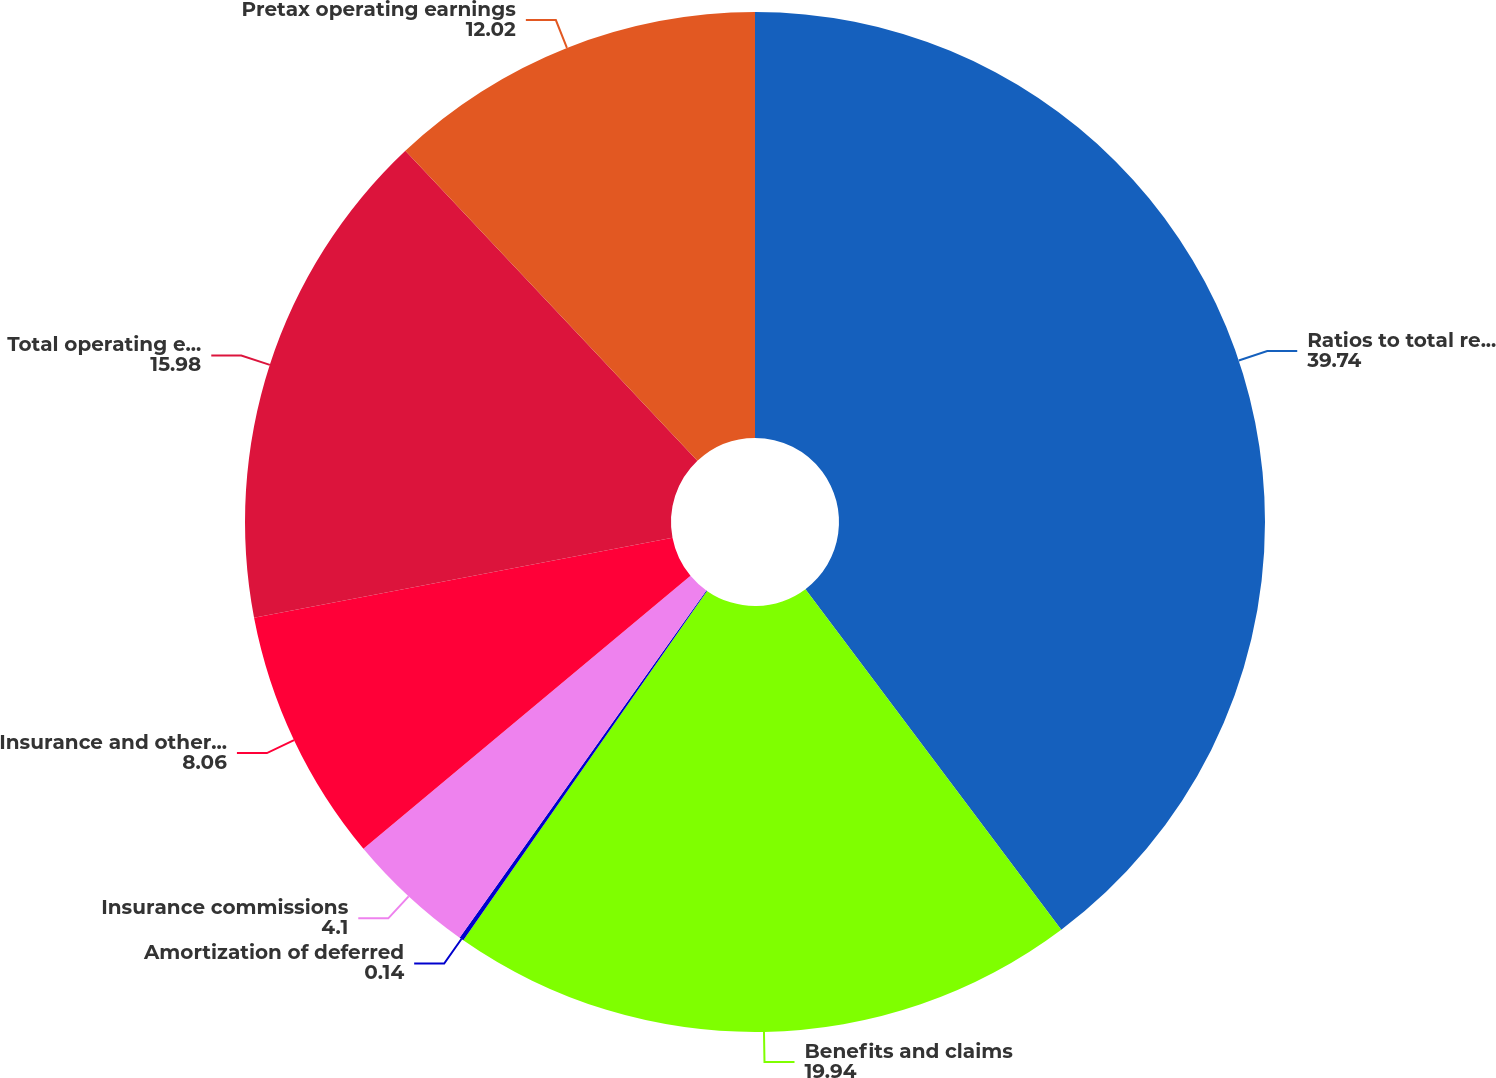Convert chart. <chart><loc_0><loc_0><loc_500><loc_500><pie_chart><fcel>Ratios to total revenues<fcel>Benefits and claims<fcel>Amortization of deferred<fcel>Insurance commissions<fcel>Insurance and other expenses<fcel>Total operating expenses<fcel>Pretax operating earnings<nl><fcel>39.74%<fcel>19.94%<fcel>0.14%<fcel>4.1%<fcel>8.06%<fcel>15.98%<fcel>12.02%<nl></chart> 